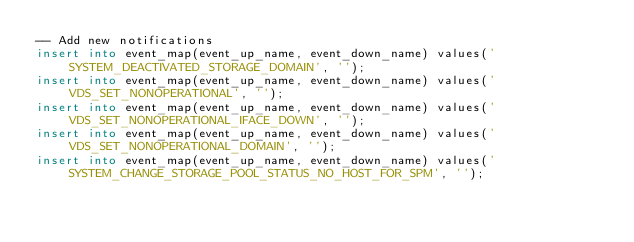<code> <loc_0><loc_0><loc_500><loc_500><_SQL_>-- Add new notifications
insert into event_map(event_up_name, event_down_name) values('SYSTEM_DEACTIVATED_STORAGE_DOMAIN', '');
insert into event_map(event_up_name, event_down_name) values('VDS_SET_NONOPERATIONAL', '');
insert into event_map(event_up_name, event_down_name) values('VDS_SET_NONOPERATIONAL_IFACE_DOWN', '');
insert into event_map(event_up_name, event_down_name) values('VDS_SET_NONOPERATIONAL_DOMAIN', '');
insert into event_map(event_up_name, event_down_name) values('SYSTEM_CHANGE_STORAGE_POOL_STATUS_NO_HOST_FOR_SPM', '');
</code> 